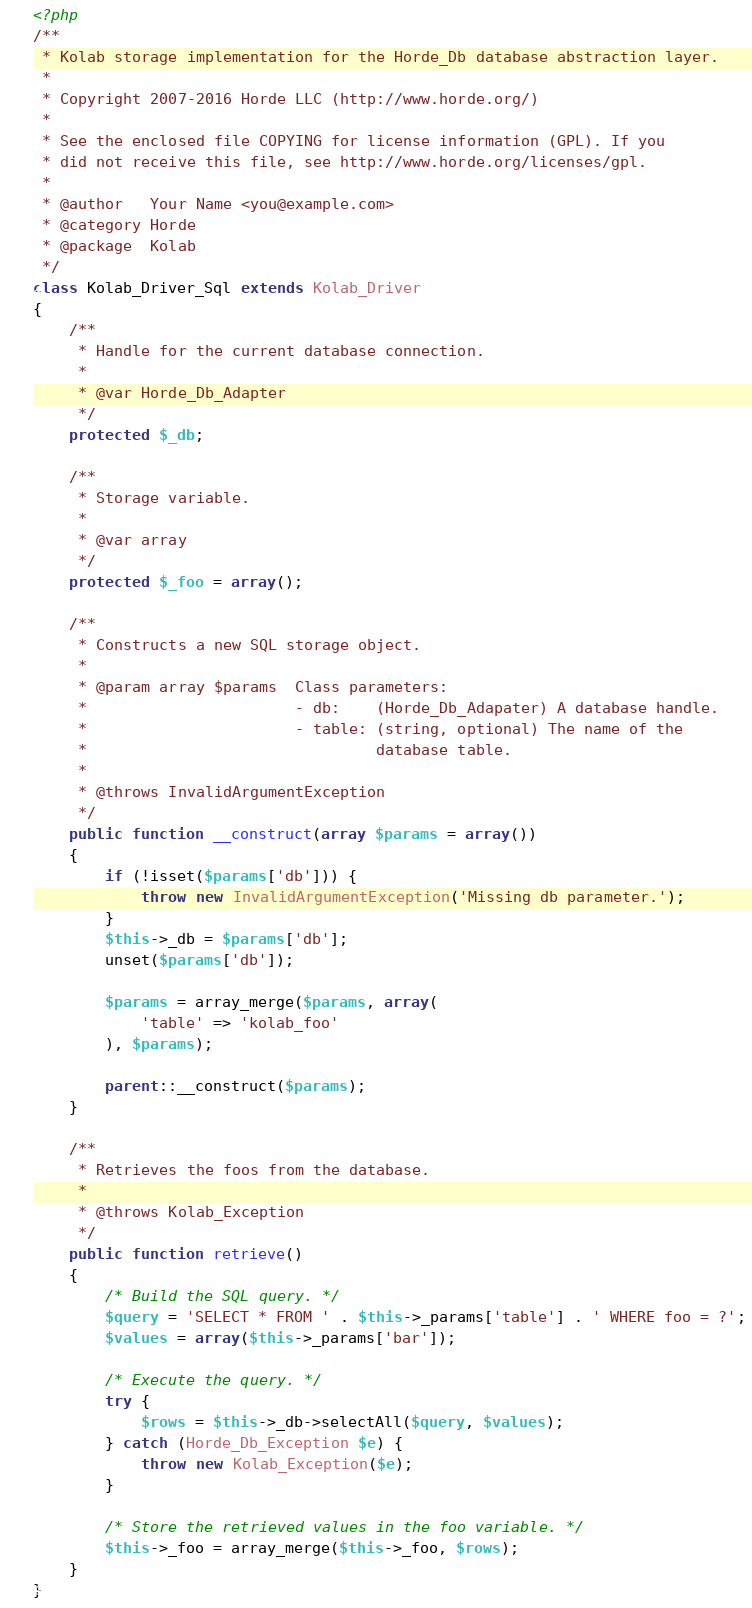Convert code to text. <code><loc_0><loc_0><loc_500><loc_500><_PHP_><?php
/**
 * Kolab storage implementation for the Horde_Db database abstraction layer.
 *
 * Copyright 2007-2016 Horde LLC (http://www.horde.org/)
 *
 * See the enclosed file COPYING for license information (GPL). If you
 * did not receive this file, see http://www.horde.org/licenses/gpl.
 *
 * @author   Your Name <you@example.com>
 * @category Horde
 * @package  Kolab
 */
class Kolab_Driver_Sql extends Kolab_Driver
{
    /**
     * Handle for the current database connection.
     *
     * @var Horde_Db_Adapter
     */
    protected $_db;

    /**
     * Storage variable.
     *
     * @var array
     */
    protected $_foo = array();

    /**
     * Constructs a new SQL storage object.
     *
     * @param array $params  Class parameters:
     *                       - db:    (Horde_Db_Adapater) A database handle.
     *                       - table: (string, optional) The name of the
     *                                database table.
     *
     * @throws InvalidArgumentException
     */
    public function __construct(array $params = array())
    {
        if (!isset($params['db'])) {
            throw new InvalidArgumentException('Missing db parameter.');
        }
        $this->_db = $params['db'];
        unset($params['db']);

        $params = array_merge($params, array(
            'table' => 'kolab_foo'
        ), $params);

        parent::__construct($params);
    }

    /**
     * Retrieves the foos from the database.
     *
     * @throws Kolab_Exception
     */
    public function retrieve()
    {
        /* Build the SQL query. */
        $query = 'SELECT * FROM ' . $this->_params['table'] . ' WHERE foo = ?';
        $values = array($this->_params['bar']);

        /* Execute the query. */
        try {
            $rows = $this->_db->selectAll($query, $values);
        } catch (Horde_Db_Exception $e) {
            throw new Kolab_Exception($e);
        }

        /* Store the retrieved values in the foo variable. */
        $this->_foo = array_merge($this->_foo, $rows);
    }
}
</code> 